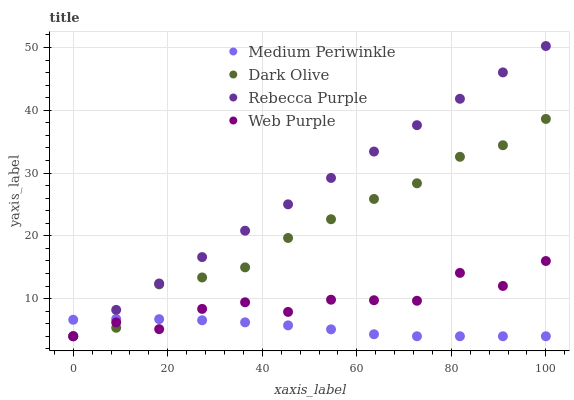Does Medium Periwinkle have the minimum area under the curve?
Answer yes or no. Yes. Does Rebecca Purple have the maximum area under the curve?
Answer yes or no. Yes. Does Dark Olive have the minimum area under the curve?
Answer yes or no. No. Does Dark Olive have the maximum area under the curve?
Answer yes or no. No. Is Rebecca Purple the smoothest?
Answer yes or no. Yes. Is Web Purple the roughest?
Answer yes or no. Yes. Is Dark Olive the smoothest?
Answer yes or no. No. Is Dark Olive the roughest?
Answer yes or no. No. Does Web Purple have the lowest value?
Answer yes or no. Yes. Does Rebecca Purple have the highest value?
Answer yes or no. Yes. Does Dark Olive have the highest value?
Answer yes or no. No. Does Web Purple intersect Rebecca Purple?
Answer yes or no. Yes. Is Web Purple less than Rebecca Purple?
Answer yes or no. No. Is Web Purple greater than Rebecca Purple?
Answer yes or no. No. 